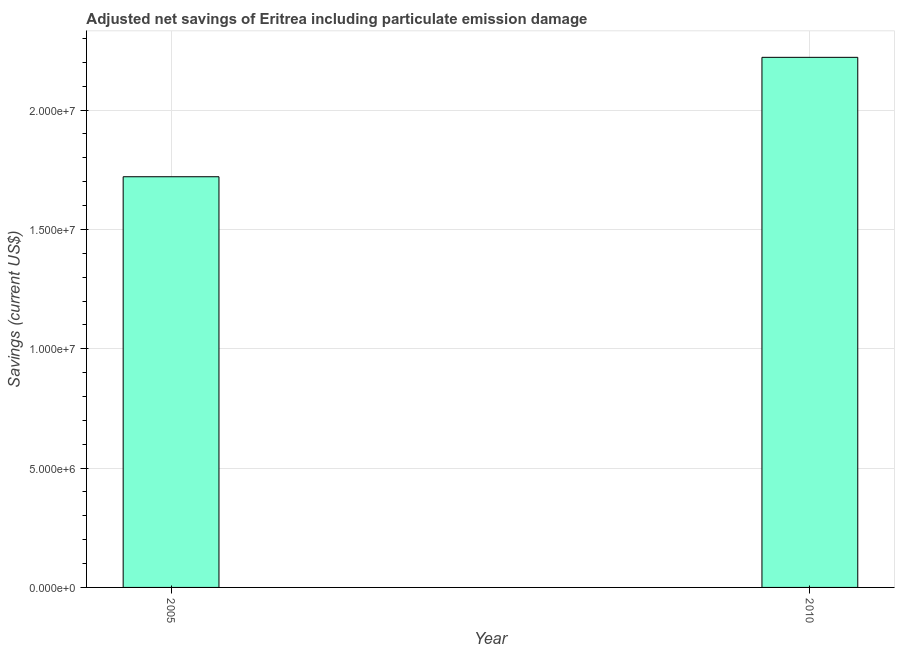Does the graph contain any zero values?
Give a very brief answer. No. What is the title of the graph?
Provide a succinct answer. Adjusted net savings of Eritrea including particulate emission damage. What is the label or title of the X-axis?
Provide a succinct answer. Year. What is the label or title of the Y-axis?
Ensure brevity in your answer.  Savings (current US$). What is the adjusted net savings in 2010?
Ensure brevity in your answer.  2.22e+07. Across all years, what is the maximum adjusted net savings?
Offer a terse response. 2.22e+07. Across all years, what is the minimum adjusted net savings?
Your answer should be compact. 1.72e+07. In which year was the adjusted net savings maximum?
Your answer should be compact. 2010. In which year was the adjusted net savings minimum?
Your answer should be very brief. 2005. What is the sum of the adjusted net savings?
Your response must be concise. 3.94e+07. What is the difference between the adjusted net savings in 2005 and 2010?
Your answer should be very brief. -5.00e+06. What is the average adjusted net savings per year?
Your response must be concise. 1.97e+07. What is the median adjusted net savings?
Ensure brevity in your answer.  1.97e+07. Do a majority of the years between 2010 and 2005 (inclusive) have adjusted net savings greater than 14000000 US$?
Make the answer very short. No. What is the ratio of the adjusted net savings in 2005 to that in 2010?
Provide a succinct answer. 0.78. Is the adjusted net savings in 2005 less than that in 2010?
Your response must be concise. Yes. In how many years, is the adjusted net savings greater than the average adjusted net savings taken over all years?
Your answer should be very brief. 1. How many bars are there?
Ensure brevity in your answer.  2. Are all the bars in the graph horizontal?
Your response must be concise. No. How many years are there in the graph?
Offer a terse response. 2. What is the difference between two consecutive major ticks on the Y-axis?
Ensure brevity in your answer.  5.00e+06. Are the values on the major ticks of Y-axis written in scientific E-notation?
Provide a short and direct response. Yes. What is the Savings (current US$) in 2005?
Your response must be concise. 1.72e+07. What is the Savings (current US$) in 2010?
Give a very brief answer. 2.22e+07. What is the difference between the Savings (current US$) in 2005 and 2010?
Offer a terse response. -5.00e+06. What is the ratio of the Savings (current US$) in 2005 to that in 2010?
Ensure brevity in your answer.  0.78. 